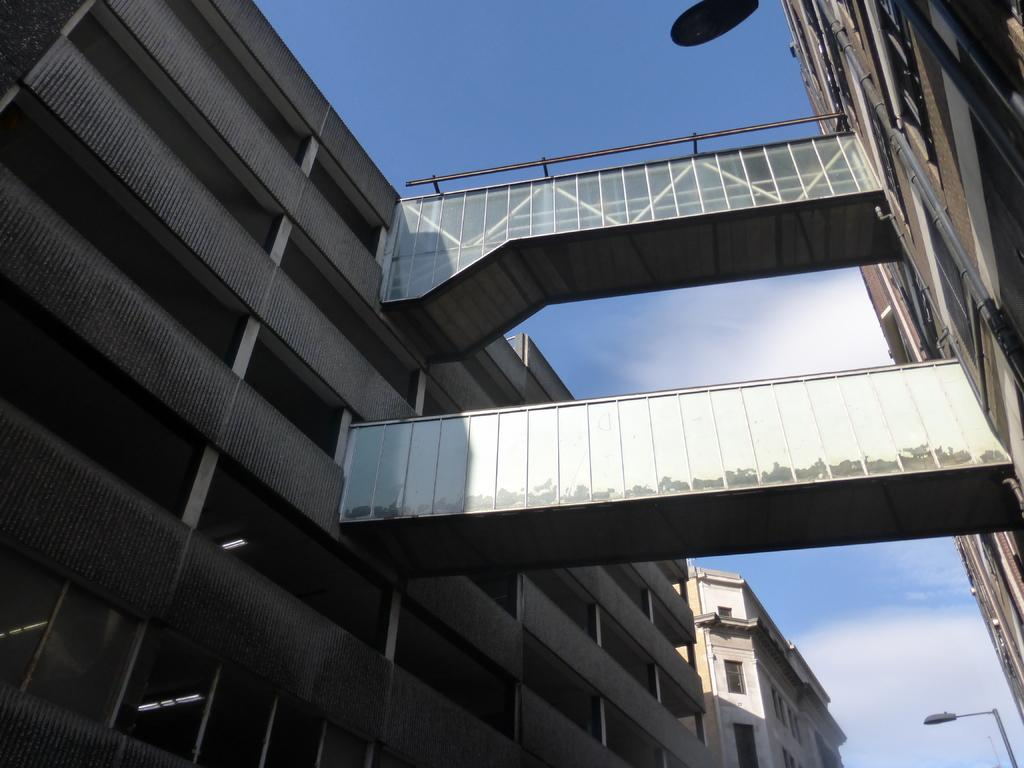How many buildings can be seen in the image? There are two buildings in the image. How are the buildings connected? There are two bridges connecting the buildings. Where are the bridges located in the image? The bridges are in the middle of the image. What can be seen in the background of the image? The sky is visible in the background of the image. What type of meal is being exchanged on the pipe in the image? There is no pipe or meal present in the image; it features two buildings connected by two bridges. 